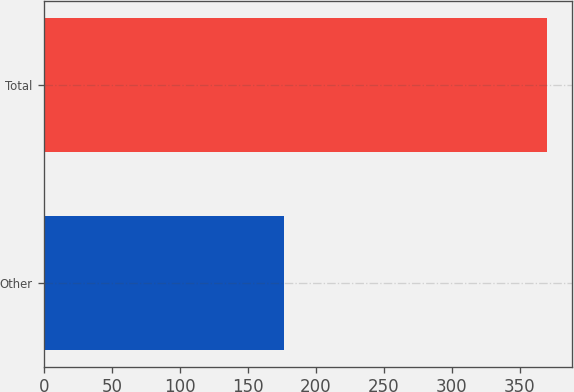Convert chart. <chart><loc_0><loc_0><loc_500><loc_500><bar_chart><fcel>Other<fcel>Total<nl><fcel>177<fcel>370<nl></chart> 